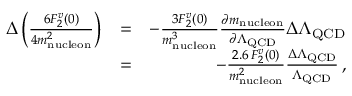<formula> <loc_0><loc_0><loc_500><loc_500>\begin{array} { r l r } { \Delta \left ( \frac { 6 F _ { 2 } ^ { v } ( 0 ) } { 4 m _ { n u c l e o n } ^ { 2 } } \right ) } & { = } & { - \frac { 3 F _ { 2 } ^ { v } ( 0 ) } { m _ { n u c l e o n } ^ { 3 } } \frac { \partial m _ { n u c l e o n } } { \partial \Lambda _ { Q C D } } \Delta \Lambda _ { Q C D } } \\ & { = } & { - \frac { 2 . 6 \, F _ { 2 } ^ { v } ( 0 ) } { m _ { n u c l e o n } ^ { 2 } } \frac { \Delta \Lambda _ { Q C D } } { \Lambda _ { Q C D } } \, , } \end{array}</formula> 